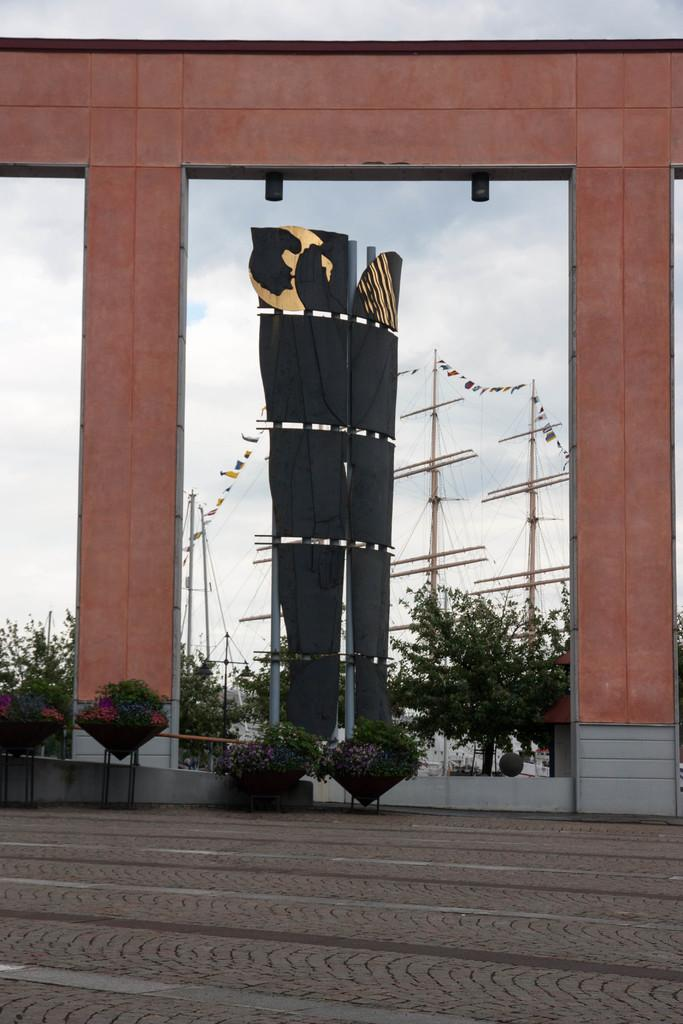What type of vertical structures can be seen in the image? There are poles and pillars in the image. What type of natural elements are present in the image? There are trees and plants in the image. What color are the black objects in the image? The black objects in the image are black. What is the path used for in the image? The path at the bottom of the image might be used for walking or driving. What is visible in the background of the image? The sky is visible in the background of the image. How many chairs are visible in the image? There are no chairs present in the image. Can you describe the sheep in the image? There are no sheep present in the image. 